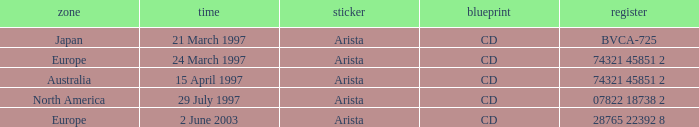What's listed for the Label with a Date of 29 July 1997? Arista. 